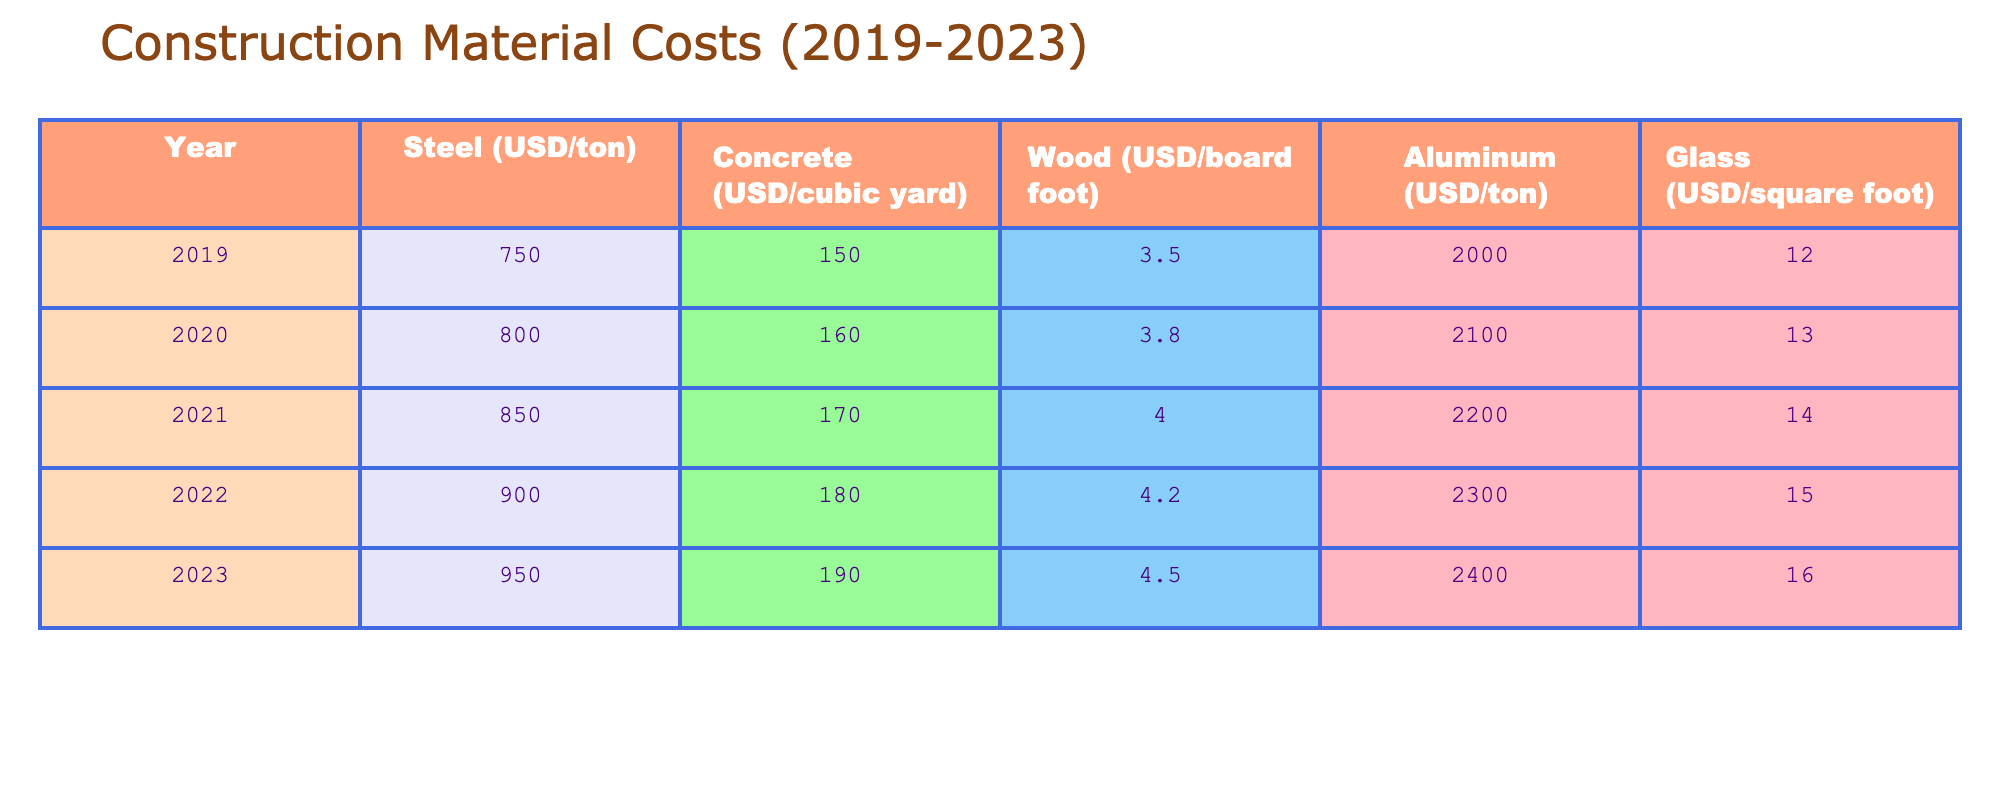What was the cost of Steel in 2020? The cost of Steel in 2020 is directly listed in the table under the "Steel" column and for the year "2020." The value provided is 800 USD/ton.
Answer: 800 USD/ton What year saw the highest cost for Aluminum? By examining the Aluminum column across all years, the highest cost is found in 2023, which is 2400 USD/ton.
Answer: 2023 What is the difference in cost of Concrete between 2019 and 2023? The cost of Concrete in 2019 is 150 USD/cubic yard, and in 2023 it is 190 USD/cubic yard. The difference can be calculated by subtracting: 190 - 150 = 40 USD/cubic yard.
Answer: 40 USD/cubic yard What's the average cost of Wood over the five years? The costs of Wood over five years are: 3.5 (2019), 3.8 (2020), 4.0 (2021), 4.2 (2022), and 4.5 (2023). To find the average, we sum these values: 3.5 + 3.8 + 4.0 + 4.2 + 4.5 = 20.0. Dividing by the number of years: 20.0 / 5 = 4.0.
Answer: 4.0 USD/board foot Is the cost of Glass in 2021 lower than the cost of Aluminum in 2022? The cost of Glass in 2021 is 14 USD/square foot, while the cost of Aluminum in 2022 is 2300 USD/ton. Since 14 USD/square foot is indeed less than 2300 USD/ton, the statement is true.
Answer: Yes In which year did the increase in Steel cost exceed 100 USD compared to the previous year? Looking at the Steel costs: In 2019 it was 750, in 2020 it was 800 (50 USD increase), in 2021 it was 850 (50 USD increase), in 2022 it was 900 (50 USD increase), and in 2023 it rose to 950 (50 USD increase). There is no year where the increase exceeds 100 USD.
Answer: None What was the total cost for all materials in 2023? To find the total, we add all costs for 2023: Steel (950) + Concrete (190) + Wood (4.5) + Aluminum (2400) + Glass (16) = 950 + 190 + 4.5 + 2400 + 16 = 2560.5 USD.
Answer: 2560.5 USD Did the cost of Concrete increase every year from 2019 to 2023? By examining the Concrete costs for each year, we see an increase from 150 (2019) to 160 (2020), 170 (2021), 180 (2022), and finally 190 (2023). Since all values show an incremental increase, the answer is yes.
Answer: Yes What was the maximum increase in the cost of Wood from one year to the next during the period? The costs of Wood are: 3.5 (2019), 3.8 (2020), 4.0 (2021), 4.2 (2022), and 4.5 (2023). The increases are: 0.3 (2019-2020), 0.2 (2020-2021), 0.2 (2021-2022), and 0.3 (2022-2023). The maximum increase is 0.3 USD/board foot.
Answer: 0.3 USD/board foot 